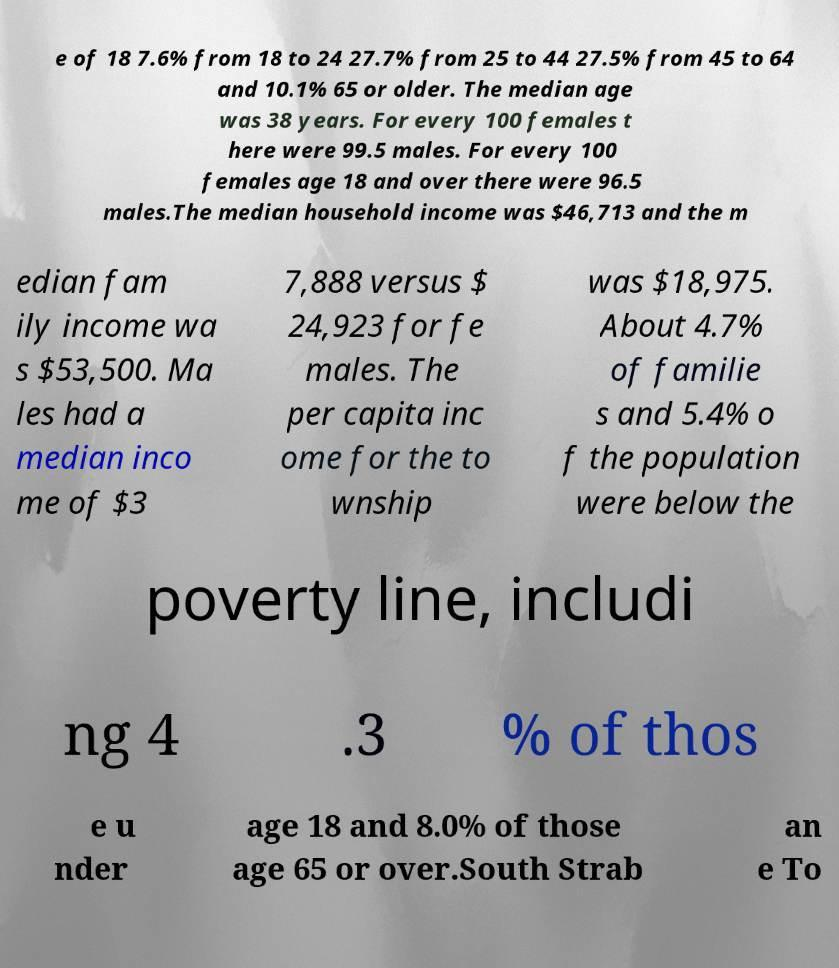Could you extract and type out the text from this image? e of 18 7.6% from 18 to 24 27.7% from 25 to 44 27.5% from 45 to 64 and 10.1% 65 or older. The median age was 38 years. For every 100 females t here were 99.5 males. For every 100 females age 18 and over there were 96.5 males.The median household income was $46,713 and the m edian fam ily income wa s $53,500. Ma les had a median inco me of $3 7,888 versus $ 24,923 for fe males. The per capita inc ome for the to wnship was $18,975. About 4.7% of familie s and 5.4% o f the population were below the poverty line, includi ng 4 .3 % of thos e u nder age 18 and 8.0% of those age 65 or over.South Strab an e To 